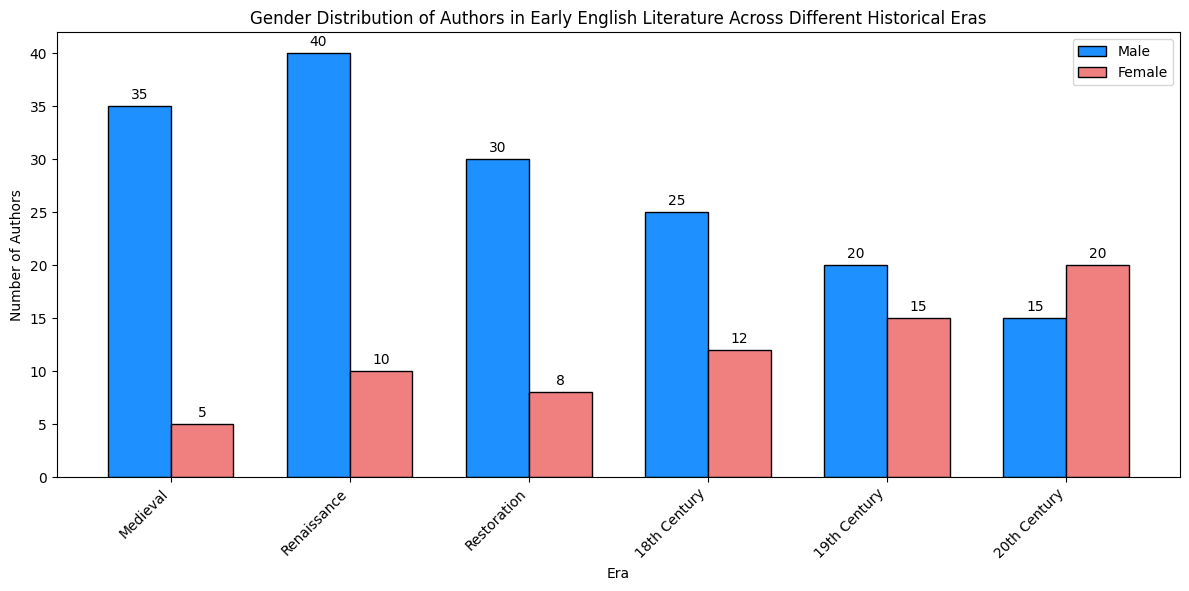How many male and female authors were there in the Medieval era combined? Add the counts of male and female authors in the Medieval era, 35 (male) + 5 (female) = 40
Answer: 40 Which era has the highest number of female authors? Look at the heights of the bars for female authors in each era. The tallest bar is in the 20th Century era with 20 female authors.
Answer: 20th Century Which era has the smallest disparity between male and female authors? Calculate the difference between male and female authors for each era: Medieval (30), Renaissance (30), Restoration (22), 18th Century (13), 19th Century (5), 20th Century (5). The smallest disparity is 5, occurring in the 19th and 20th Centuries.
Answer: 19th Century, 20th Century In which era did the number of female authors exceed 10? Check the female author counts in each era. The Renaissance, 18th Century, 19th Century, and 20th Century all have female authors exceeding 10.
Answer: Renaissance, 18th Century, 19th Century, 20th Century Compare the total number of authors (both genders) in the Renaissance and 18th Century. Which era has more authors? Calculate the total number of authors for each era: Renaissance (50), 18th Century (37). The Renaissance has more authors.
Answer: Renaissance What is the ratio of male to female authors in the Restoration era? The counts are 30 male and 8 female authors in the Restoration era. The ratio is 30:8, which simplifies to 15:4.
Answer: 15:4 What is the average number of female authors across all eras? Sum the counts of female authors (5 + 10 + 8 + 12 + 15 + 20 = 70) and divide by the number of eras (6). The average is 70/6 ≈ 11.67.
Answer: 11.67 By how much did the number of male authors decrease from the Renaissance to the 20th Century? Subtract the number of male authors in the 20th Century (15) from that in the Renaissance (40). The decrease is 40 - 15 = 25.
Answer: 25 Which gender saw a greater overall increase in authors from the Medieval to the 20th Century era? Compare the differences: Male authors (15-35 = -20), Female authors (20-5 = 15). Female authors saw a greater increase.
Answer: Female What is the total number of authors during the Restoration era? Add the counts of male and female authors in the Restoration era, 30 (male) + 8 (female) = 38
Answer: 38 